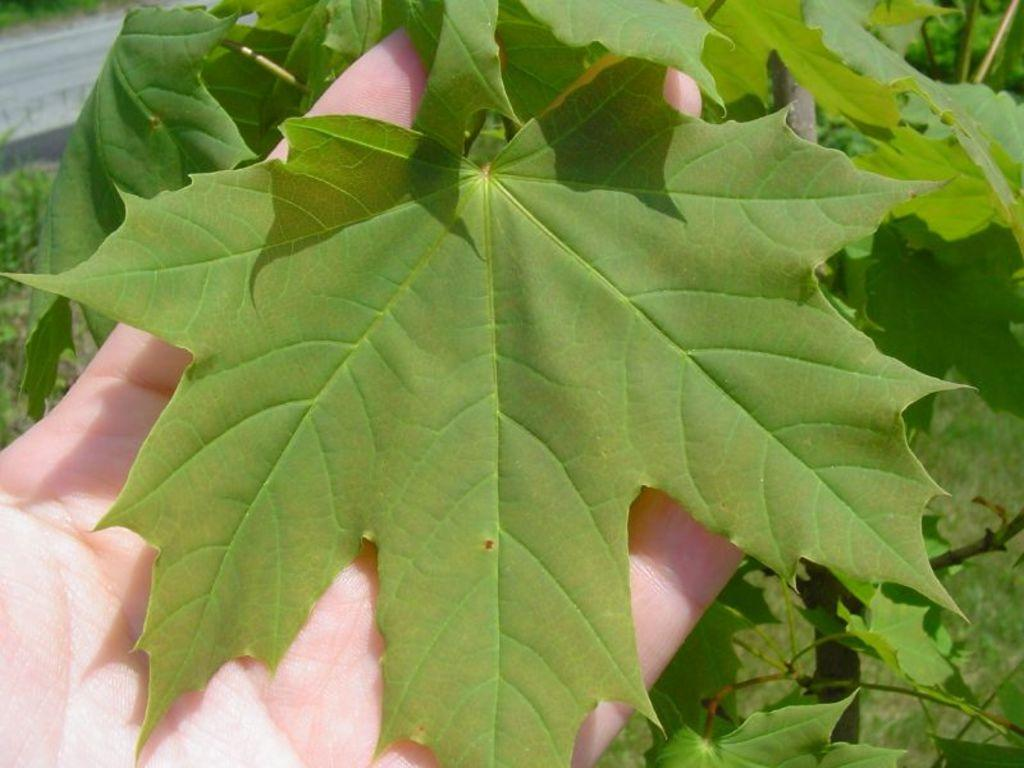What is the person's hand holding in the image? The person's hand is holding a leaf in the image. What type of vegetation can be seen in the image? There is a plant visible in the image. What can be seen in the top left corner of the image? There is a road and grass visible in the top left corner of the image. What is the pig teaching the students in the image? There is no pig or students present in the image, so it is not possible to answer that question. 